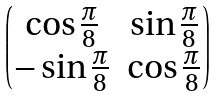Convert formula to latex. <formula><loc_0><loc_0><loc_500><loc_500>\begin{pmatrix} \cos \frac { \pi } { 8 } & \sin \frac { \pi } { 8 } \\ - \sin \frac { \pi } { 8 } & \cos \frac { \pi } { 8 } \\ \end{pmatrix}</formula> 